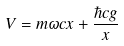<formula> <loc_0><loc_0><loc_500><loc_500>V = m \omega c x + \frac { \hbar { c } g } { x }</formula> 